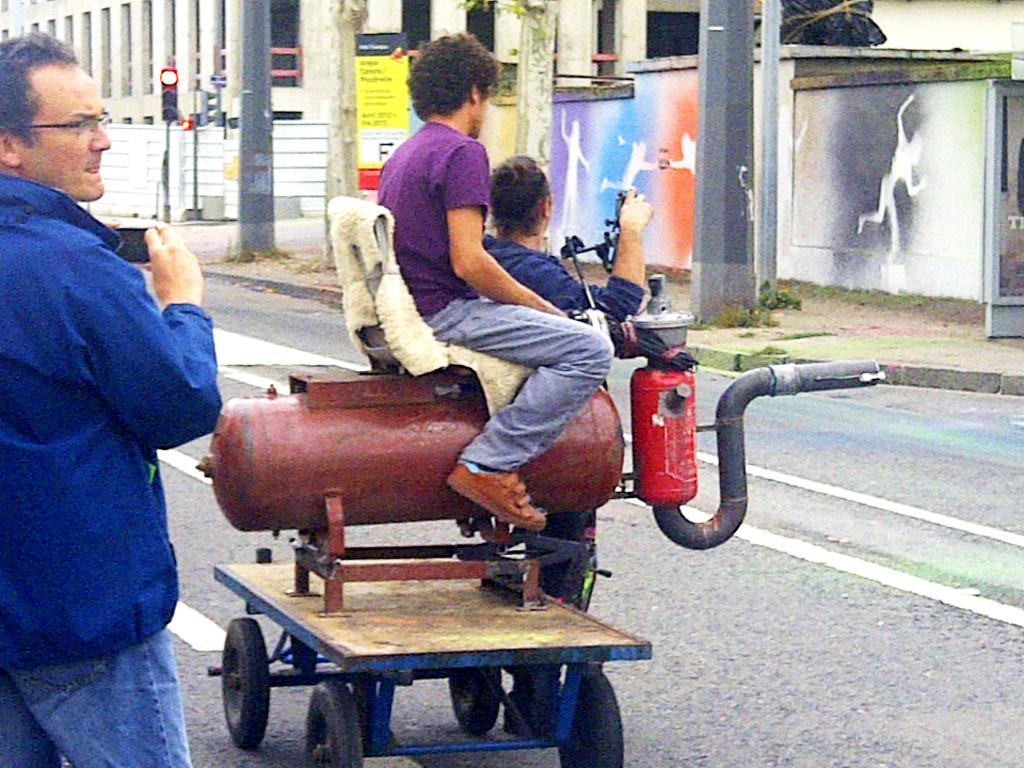Could you give a brief overview of what you see in this image? In this image, we can see a person on the tank which is attached to the moving trolley. There is an another person standing and wearing clothes in the middle of the image. There are poles in front of the wall. There is a building at the top of the image. There is a person on the left side of the image standing and holding a phone with his hands. 